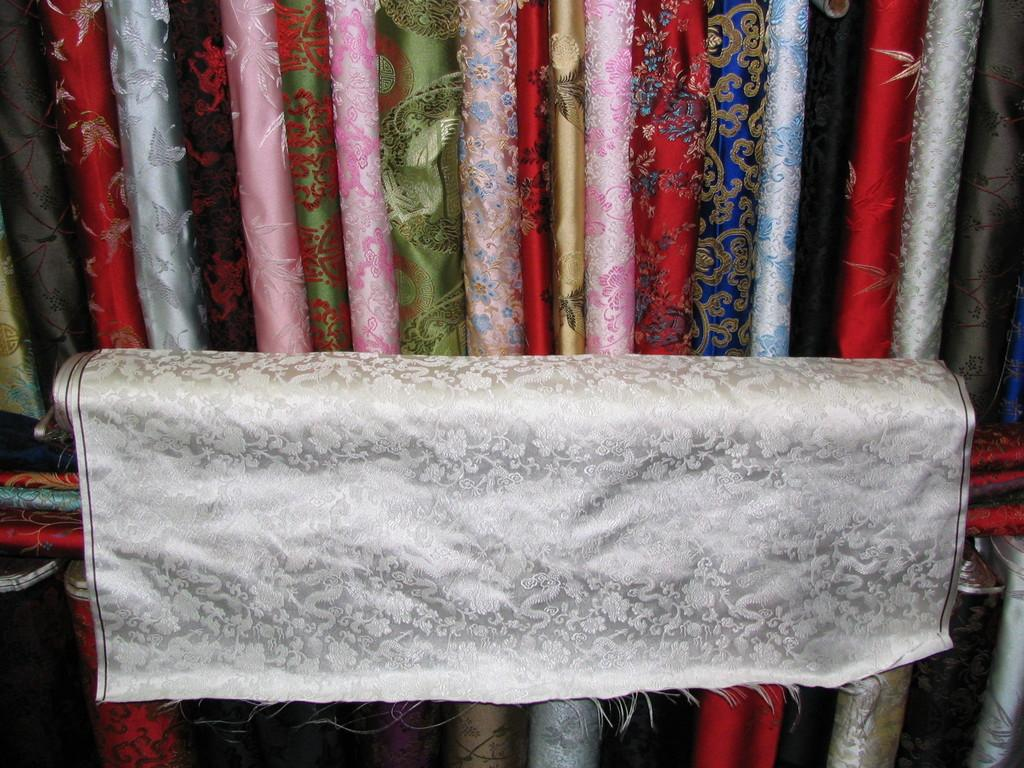What is the main subject of the image? The main subject of the image is a cloth roll. Are there any other cloth rolls visible in the image? Yes, there are multiple different types of cloth rolls visible in the image. What is the name of the war that is depicted in the image? There is no war depicted in the image; it features multiple cloth rolls. What do people believe about the cloth rolls in the image? The image does not provide any information about people's beliefs regarding the cloth rolls. 